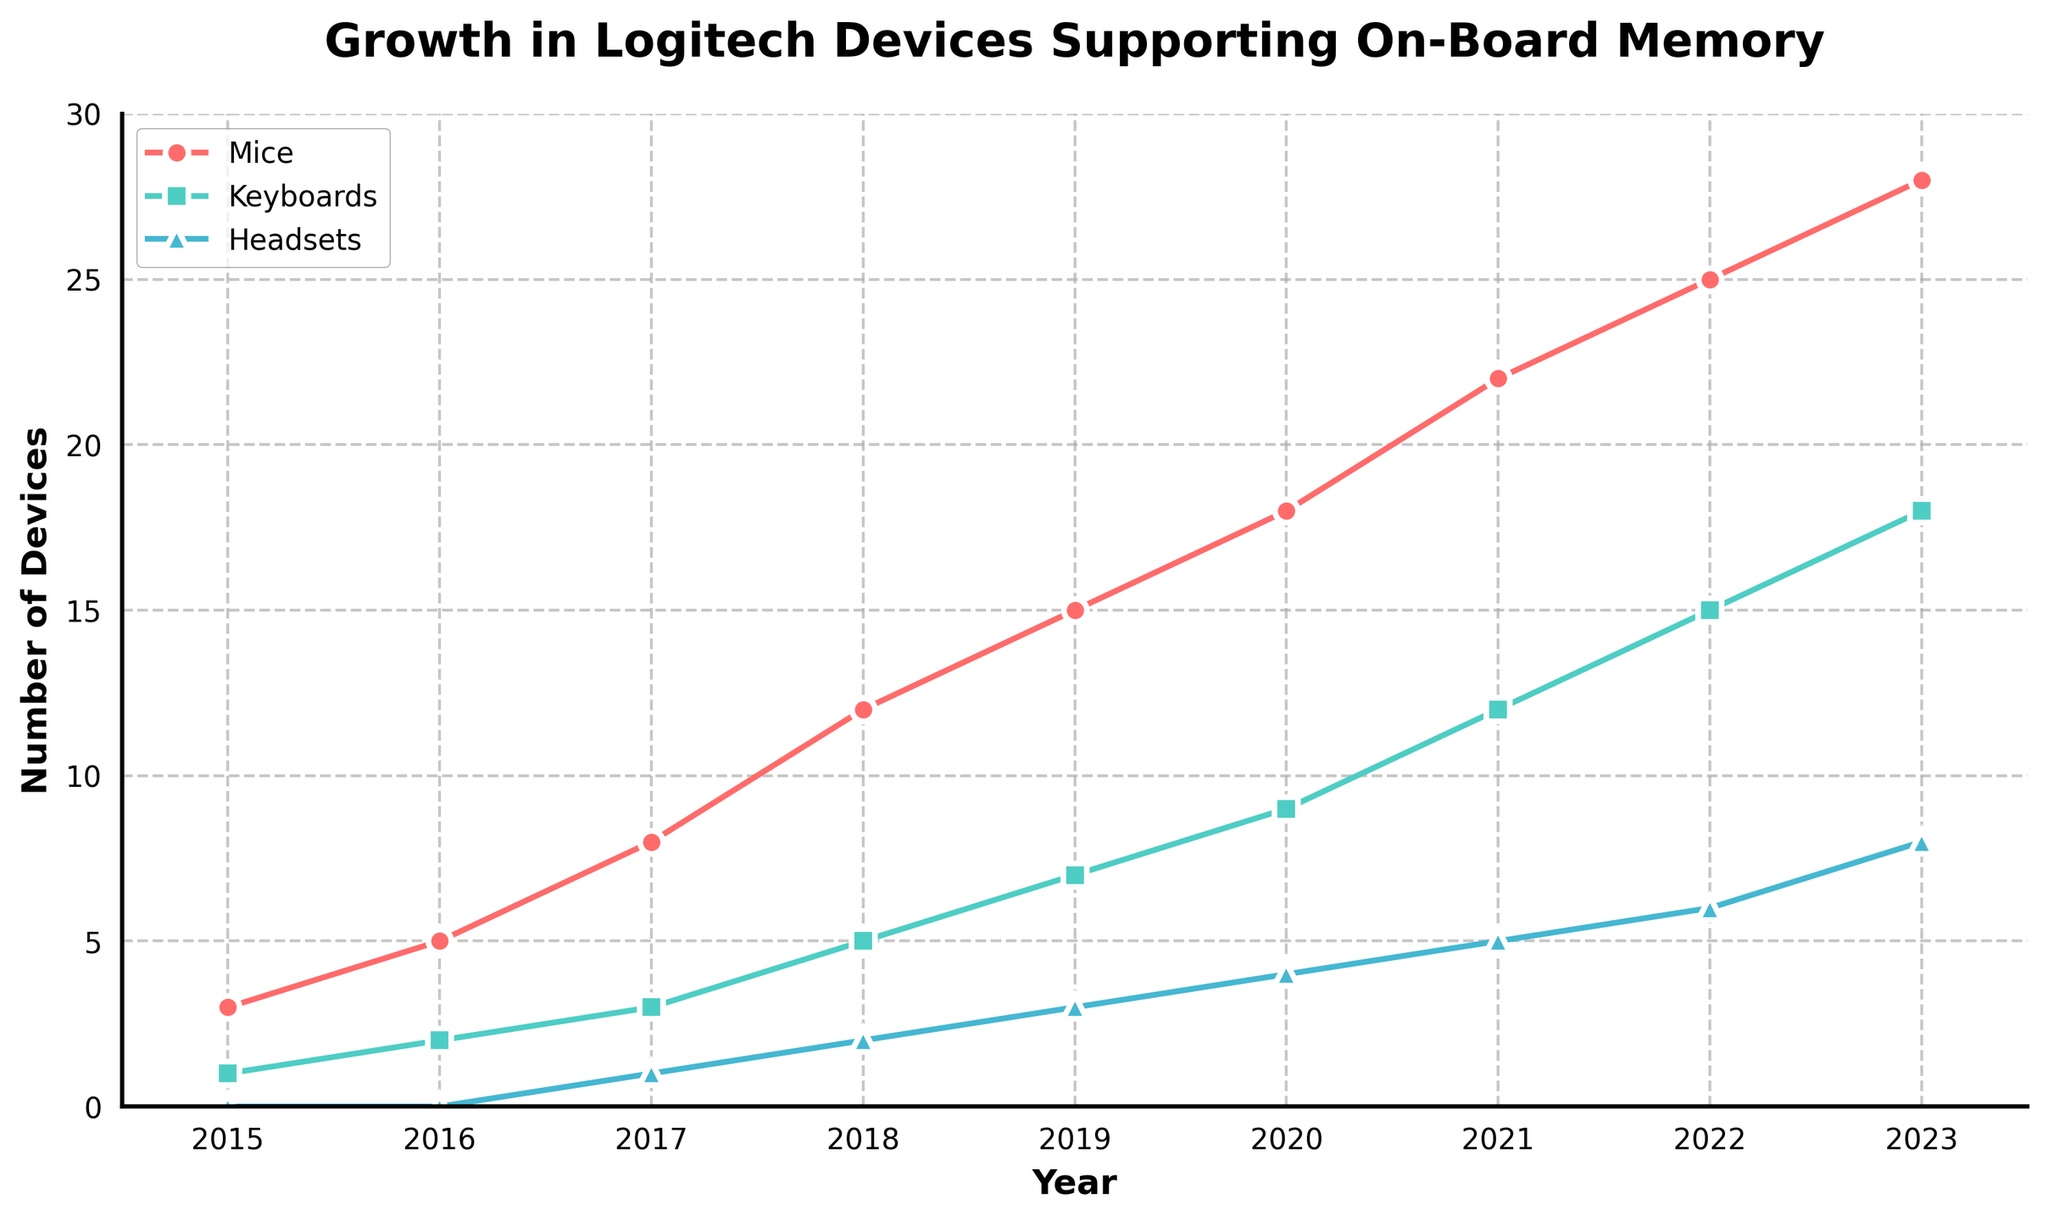What year did headsets first support on-board memory? By looking at the number of headsets supporting on-board memory features, we see that the number goes from 0 in 2016 to 1 in 2017, indicating this feature was first supported in 2017.
Answer: 2017 Which device type had the highest number of devices supporting on-board memory features in 2023? Observing the lines at the year 2023, the mice have the highest value of 28, compared to keyboards with 18 and headsets with 8.
Answer: Mice How many more mice support on-board memory features than keyboards in 2020? In 2020, the number of mice with on-board memory is 18 and the number of keyboards is 9. Subtract 9 from 18 to get 9.
Answer: 9 What is the average number of mice supporting on-board memory features over the years 2015, 2020, and 2023? Add the values for mice in the years 2015 (3), 2020 (18), and 2023 (28) and then divide by 3. The sum is 3 + 18 + 28 = 49, and 49 / 3 equals approximately 16.33.
Answer: 16.33 In which year did the total number of devices (mice, keyboards, headsets) supporting on-board memory reach or exceed 30 for the first time? Summing the total number of devices for each year, 2021 is the first year where the sum reaches or exceeds 30. 22 (mice) + 12 (keyboards) + 5 (headsets) = 39.
Answer: 2021 Which device type saw the highest increase in the number of devices supporting on-board memory features from 2018 to 2023? For mice, the number increased from 12 in 2018 to 28 in 2023 which is an increase of 16. For keyboards, it increased from 5 to 18 (an increase of 13), and for headsets from 2 to 8 (an increase of 6). Thus, mice saw the highest increase of 16.
Answer: Mice What is the total number of devices supporting on-board memory features in 2019? Add the values for mice (15), keyboards (7), and headsets (3) in 2019. 15 + 7 + 3 = 25.
Answer: 25 Which color line indicates the number of keyboards supporting on-board memory features? The line representing keyboards is identified by its color, which is green.
Answer: Green 